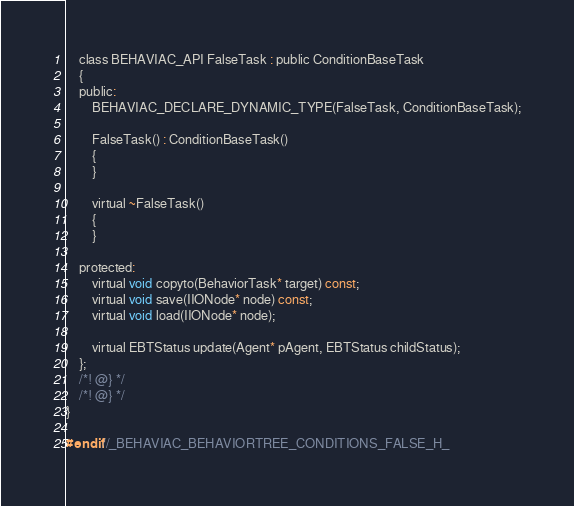Convert code to text. <code><loc_0><loc_0><loc_500><loc_500><_C_>    class BEHAVIAC_API FalseTask : public ConditionBaseTask
    {
    public:
        BEHAVIAC_DECLARE_DYNAMIC_TYPE(FalseTask, ConditionBaseTask);

        FalseTask() : ConditionBaseTask()
        {
        }

        virtual ~FalseTask()
        {
        }

    protected:
        virtual void copyto(BehaviorTask* target) const;
        virtual void save(IIONode* node) const;
        virtual void load(IIONode* node);

        virtual EBTStatus update(Agent* pAgent, EBTStatus childStatus);
    };
    /*! @} */
    /*! @} */
}

#endif//_BEHAVIAC_BEHAVIORTREE_CONDITIONS_FALSE_H_
</code> 